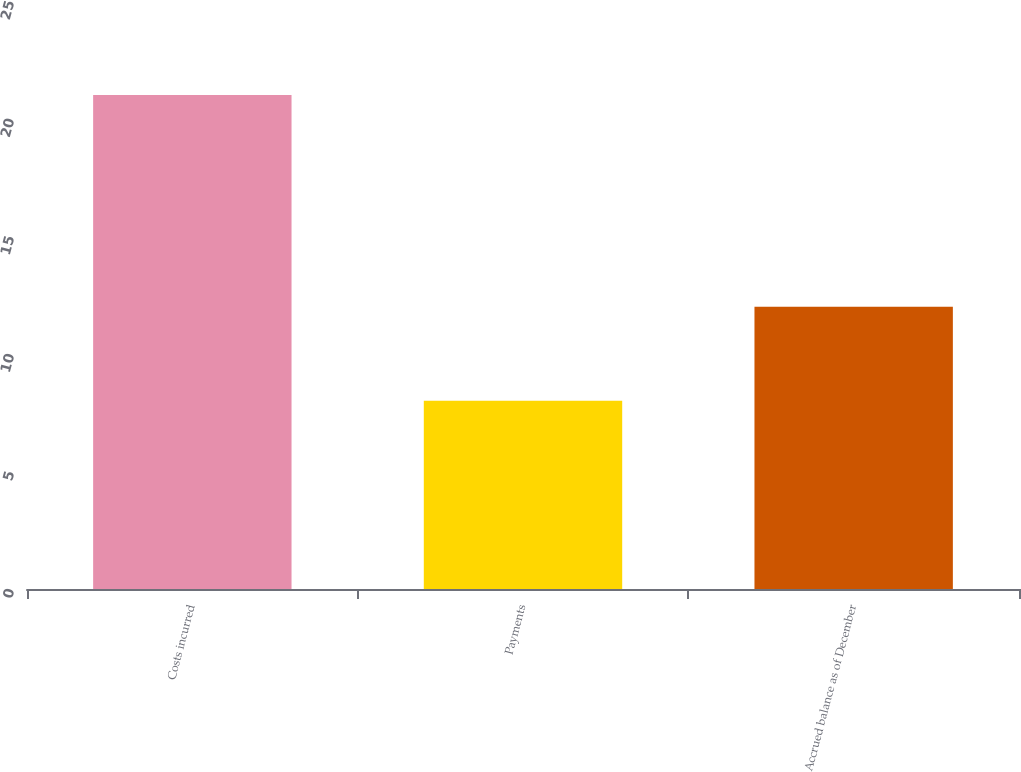Convert chart. <chart><loc_0><loc_0><loc_500><loc_500><bar_chart><fcel>Costs incurred<fcel>Payments<fcel>Accrued balance as of December<nl><fcel>21<fcel>8<fcel>12<nl></chart> 